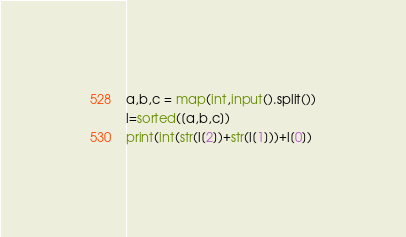Convert code to text. <code><loc_0><loc_0><loc_500><loc_500><_Python_>a,b,c = map(int,input().split())
l=sorted([a,b,c])
print(int(str(l[2])+str(l[1]))+l[0])</code> 